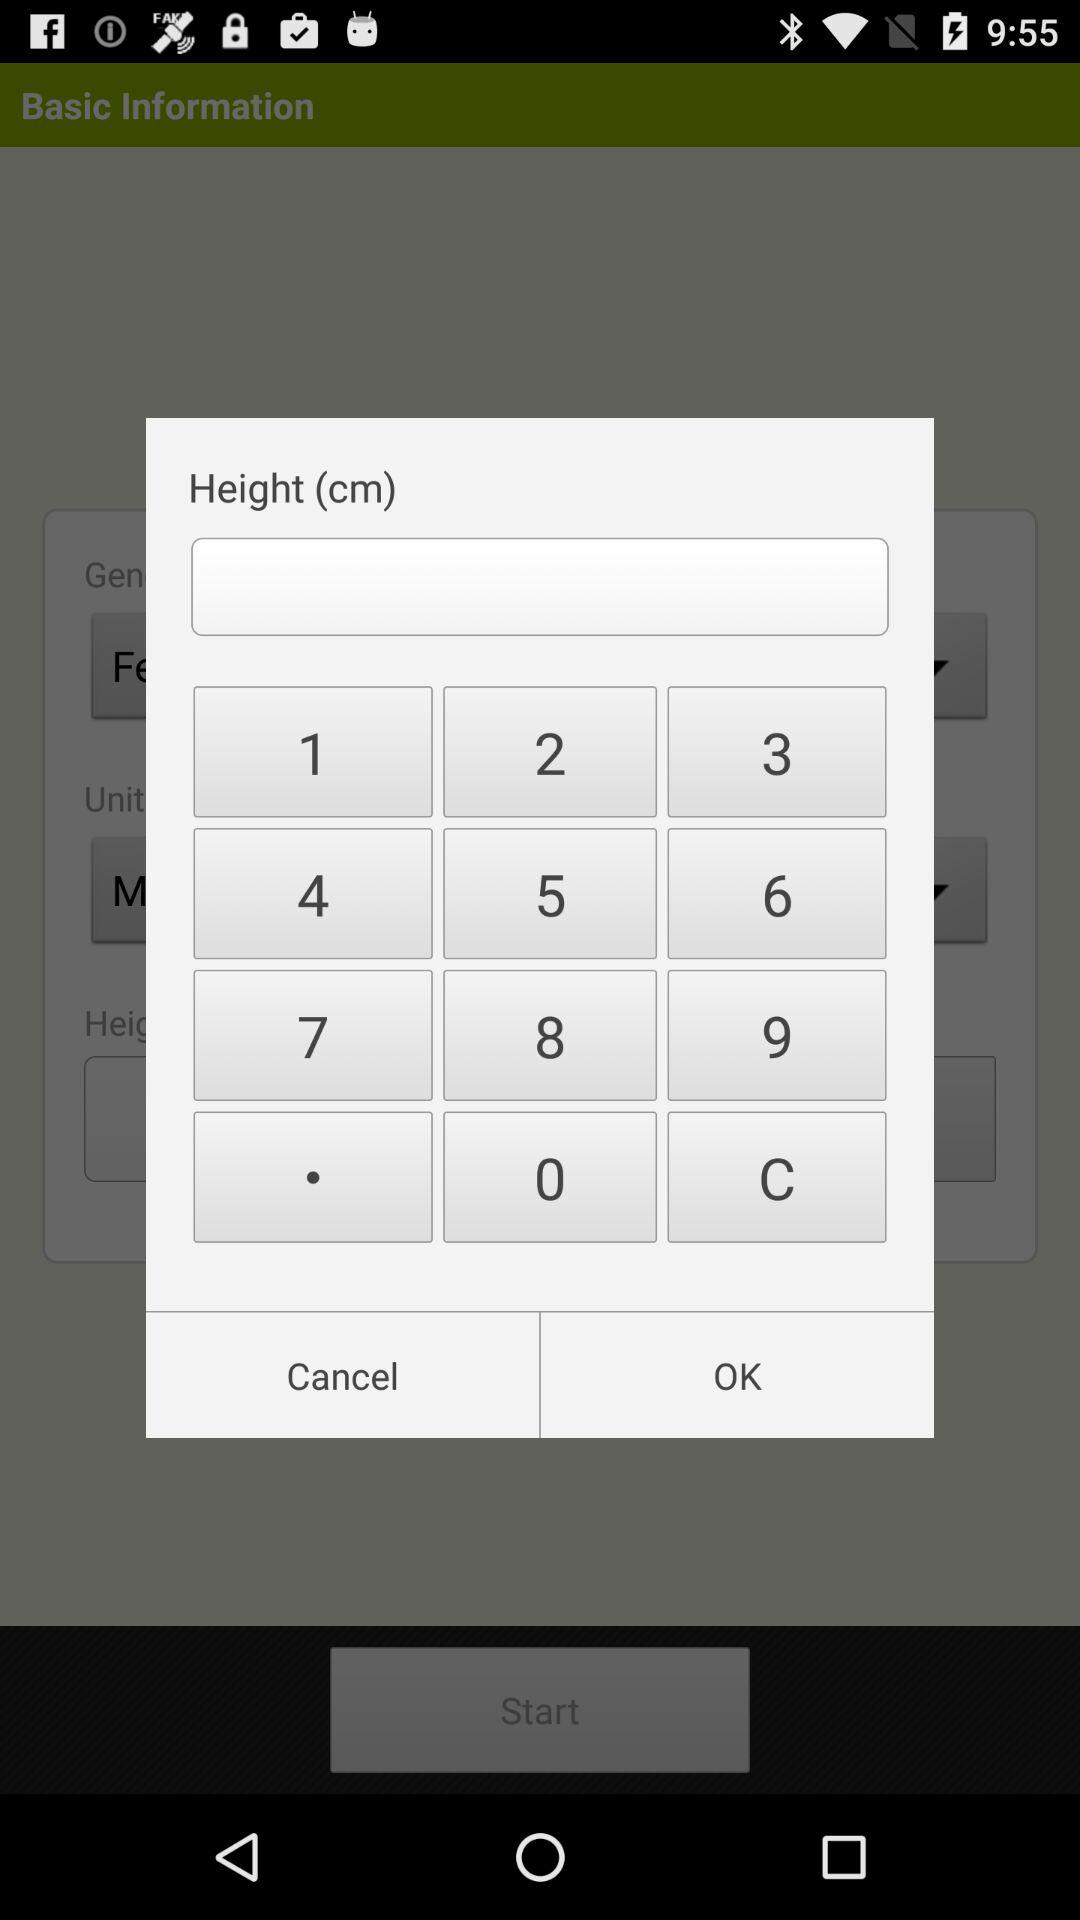What is the mentioned weight?
When the provided information is insufficient, respond with <no answer>. <no answer> 